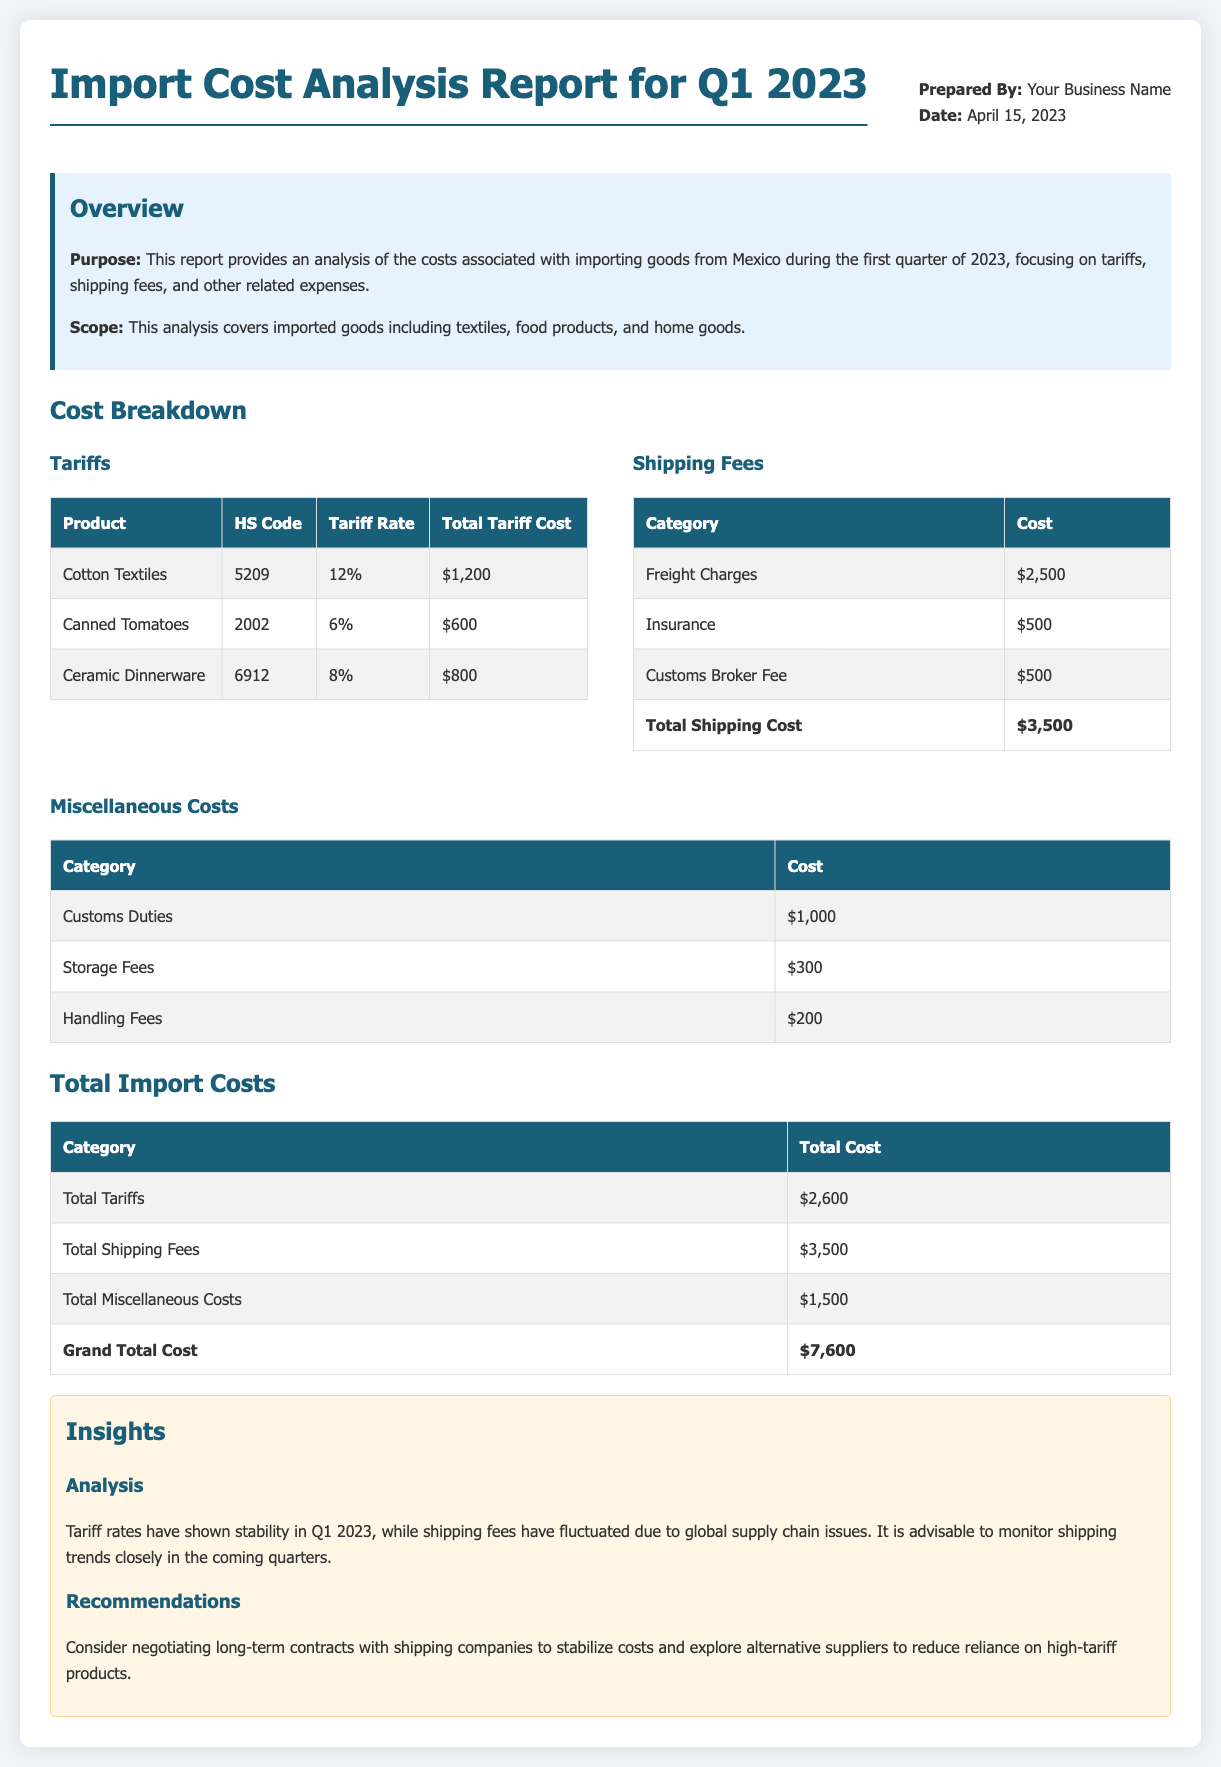What is the total tariff cost? The total tariff cost is provided under the tariffs section, which sums to $2,600.
Answer: $2,600 What is the total shipping cost? The total shipping cost is listed at the bottom of the shipping fees section, which is $3,500.
Answer: $3,500 What is the value of miscellaneous costs? The total for miscellaneous costs is provided at the end of that section, totaling $1,500.
Answer: $1,500 What is the grand total cost of imports? The grand total cost is mentioned at the end of the cost breakdown, which is $7,600.
Answer: $7,600 Which product has the highest tariff rate? The document lists Cotton Textiles with a tariff rate of 12%, which is the highest among the listed products.
Answer: Cotton Textiles What category incurs the highest shipping fee? The highest shipping fee category is Freight Charges, amounting to $2,500.
Answer: Freight Charges What is a recommendation made in the insights section? One recommendation is to consider negotiating long-term contracts with shipping companies.
Answer: Negotiate long-term contracts What is the HS code for canned tomatoes? The HS code for canned tomatoes is specifically mentioned in the tariff table, which is 2002.
Answer: 2002 Which section provides insights into the import analysis? Insights regarding the analysis can be found in the insights section of the report.
Answer: Insights section 